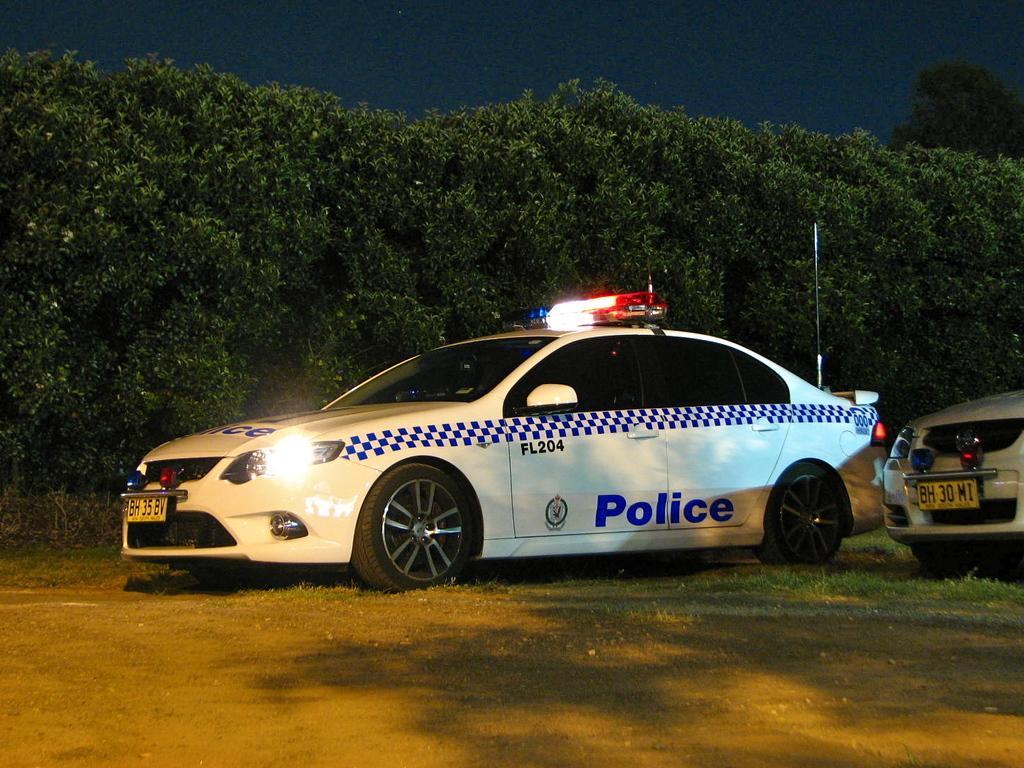In one or two sentences, can you explain what this image depicts? In this picture we can see vehicles on the ground, trees and in the background we can see the sky. 